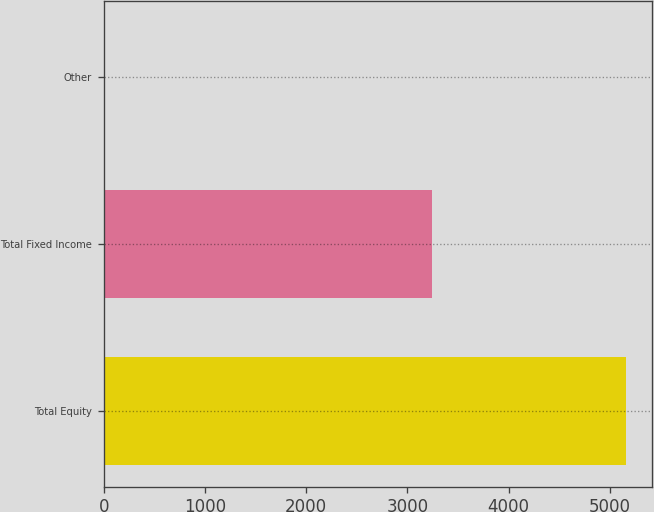<chart> <loc_0><loc_0><loc_500><loc_500><bar_chart><fcel>Total Equity<fcel>Total Fixed Income<fcel>Other<nl><fcel>5161<fcel>3242<fcel>10<nl></chart> 